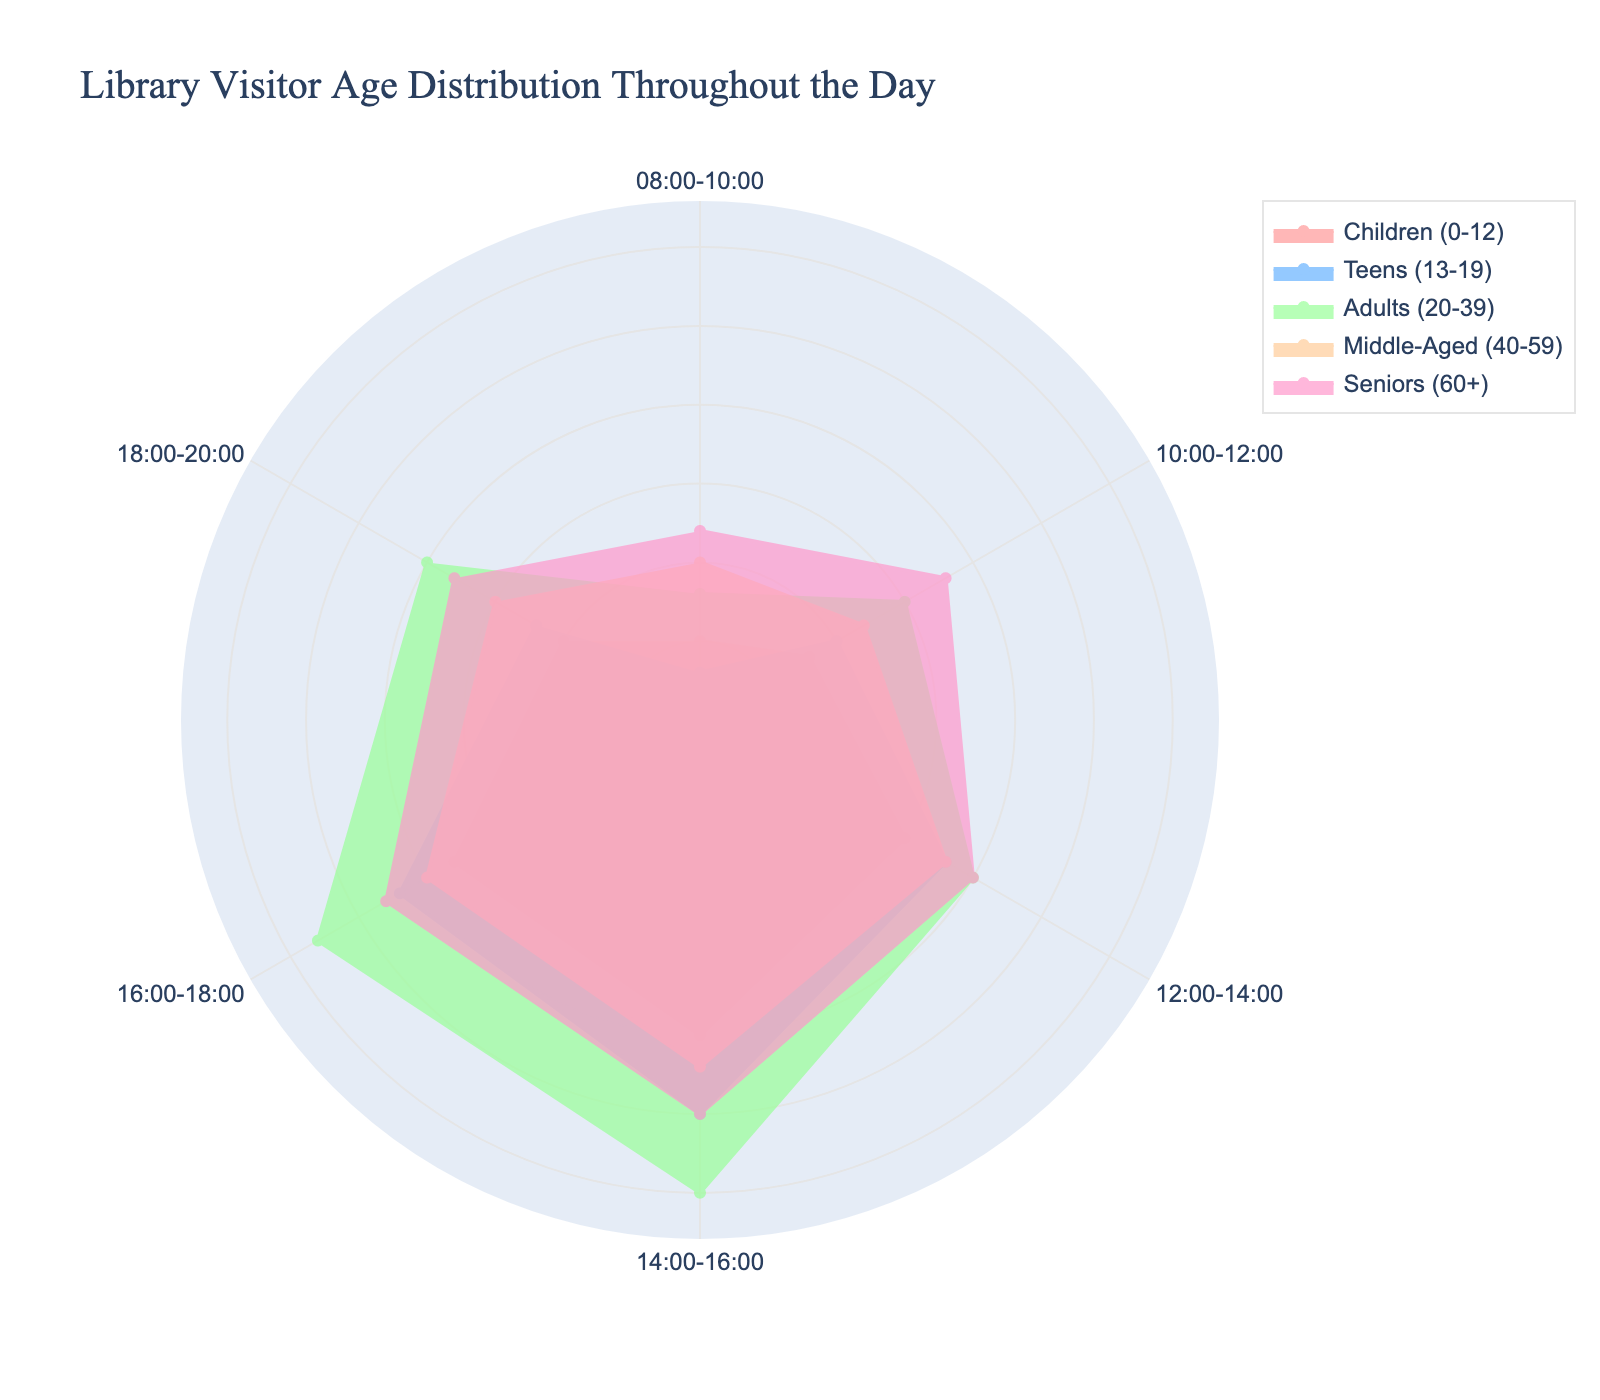What's the title of this chart? The title is usually located at the top of a chart to give an overview of what the chart represents. In this case, it reads: "Library Visitor Age Distribution Throughout the Day"
Answer: Library Visitor Age Distribution Throughout the Day How many age groups are represented in the chart? By looking at the legend or the different colored areas, you can count the number of distinct categories. Here, there are five age groups represented
Answer: 5 Which age group has the highest number of visitors between 14:00 and 16:00? To determine this, look at the values specified for the time slot 14:00-16:00 across all age groups. The largest value represents the age group with the highest number of visitors.
Answer: Adults (20-39) What is the range of the radial axis in the chart? The radial axis range can be found by looking at the outermost numbers along the axis. It typically presents the maximum data value plus a small margin to accommodate visual clarity. Here, the range extends up to a bit more than the highest frequency, which is around 33 (30 * 1.1).
Answer: 0 to approximately 33 Which two age groups have the closest number of visitors between 08:00 and 10:00? To answer this, compare the values for all age groups for the time slot 08:00-10:00 and find the two that are numerically closest.
Answer: Teens (13-19) and Adults (20-39) What is the average number of visitors for the 'Seniors (60+)' age group across all time slots? To calculate the average, sum up the values for all time slots for the 'Seniors (60+)' group and divide by the number of time slots. The values are 12, 18, 20, 25, 23, and 18. So, the sum is 116 and there are 6 time slots. The average would be 116 / 6.
Answer: 19.33 During which time period do 'Children (0-12)' have the lowest number of visitors? Look at the values for 'Children (0-12)' across all time slots and identify the smallest value.
Answer: 08:00-10:00 Compare the number of visitors for 'Teens (13-19)' and 'Middle-Aged (40-59)' groups from 18:00-20:00. Which age group has more visitors? Check the values for both groups at the 18:00-20:00 time slot. 'Teens (13-19)' have 12 visitors, while 'Middle-Aged (40-59)' have 15 visitors.
Answer: Middle-Aged (40-59) What is the total number of visitors for the 'Adults (20-39)' age group throughout the day? Sum the values of 'Adults (20-39)' for all time slots: 8 + 15 + 20 + 30 + 28 + 20 = 121.
Answer: 121 